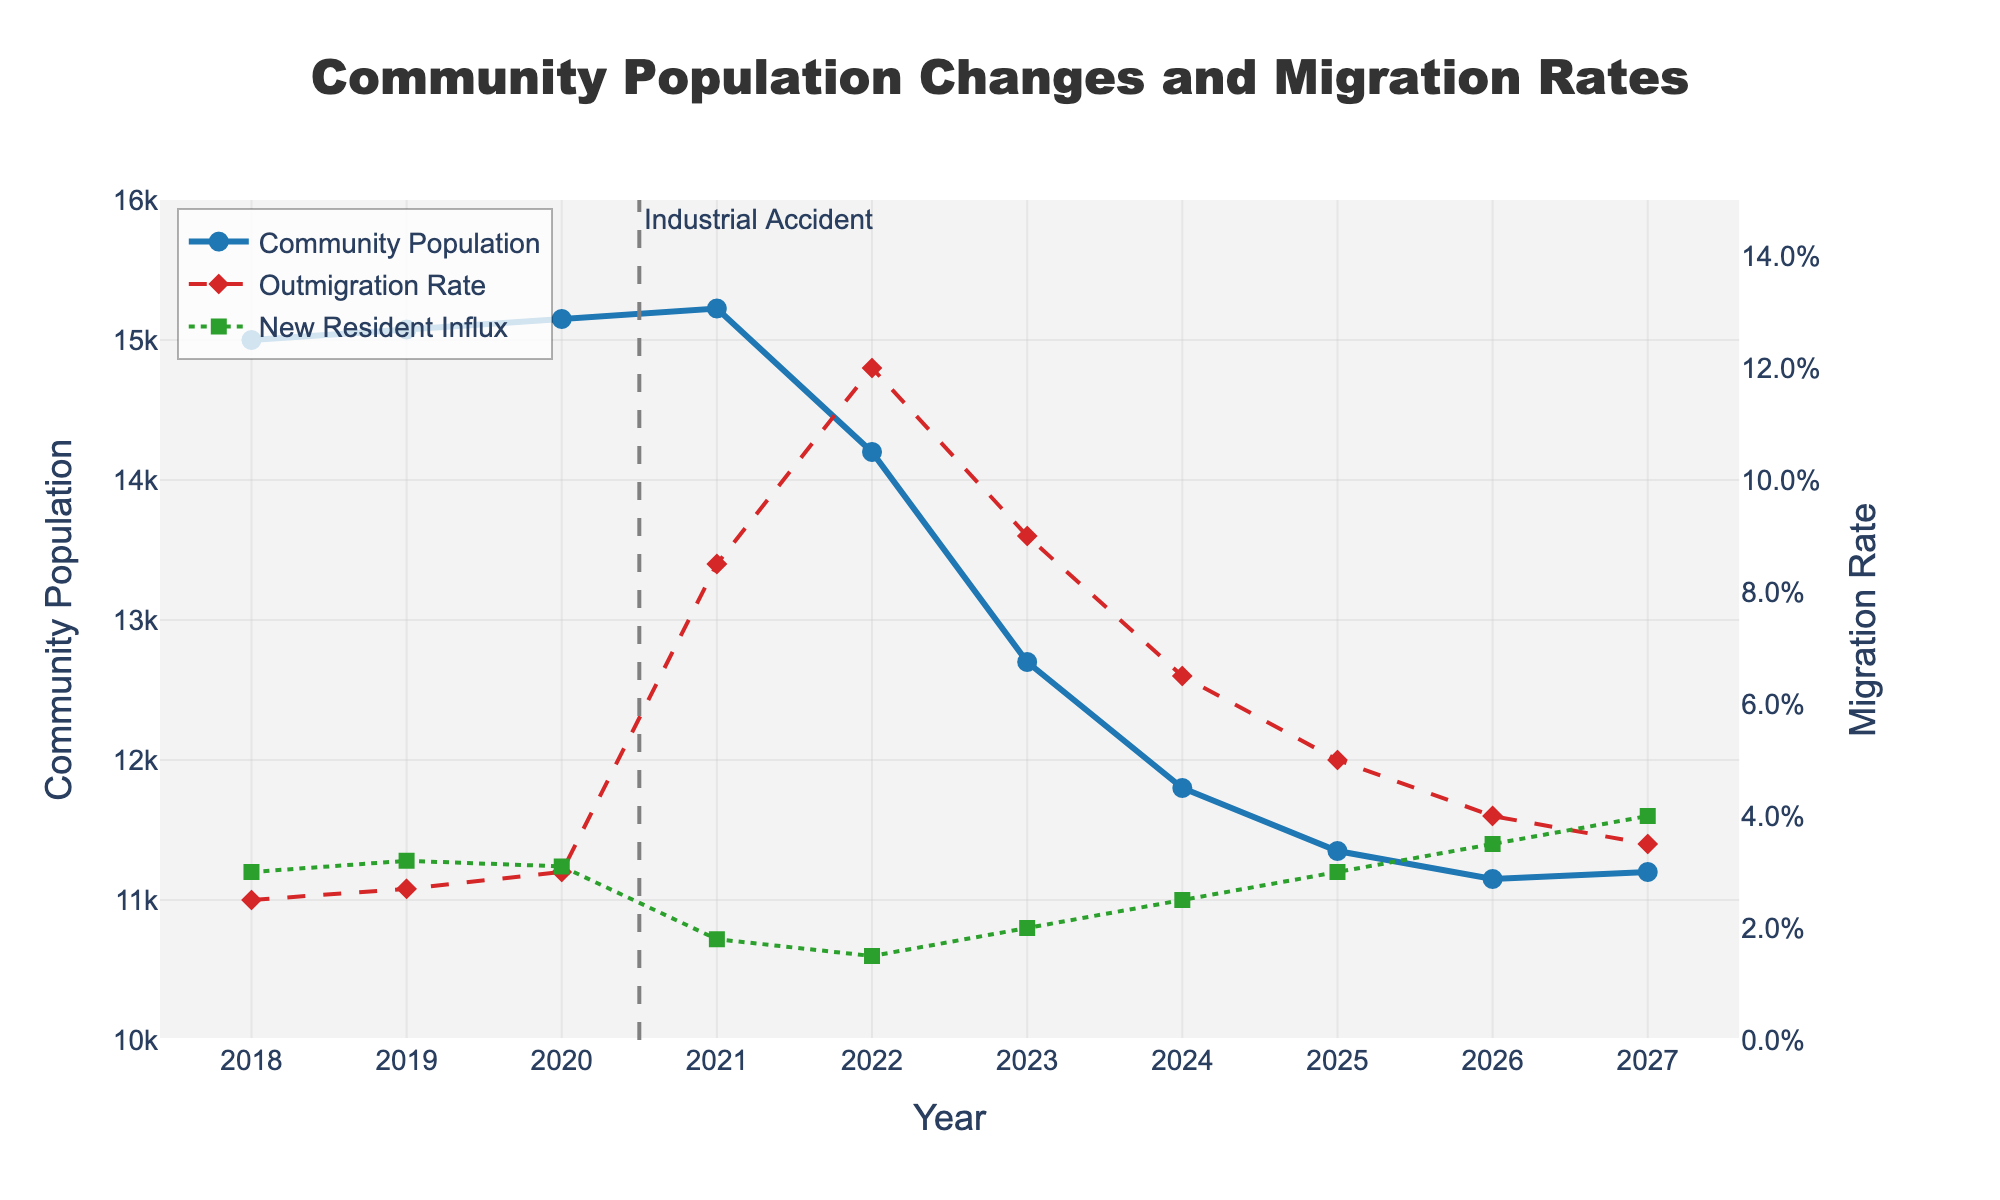What's the population trend in the community from 2018 to 2027? To determine the population trend, observe the blue line in the chart representing the 'Community Population.' From 2018 to 2020, there's a gradual increase in population. However, starting from 2021, there is a sharp decline continuing until 2027, indicating an overall decreasing trend.
Answer: Downward Trend How did the outmigration rate change from 2020 to 2022? Examine the red dashed line representing the 'Outmigration Rate.' It increases significantly from 3.0% in 2020 to 8.5% in 2021, and peaks at 12.0% in 2022.
Answer: Increased Which year had the highest new resident influx? Check the green dotted line for 'New Resident Influx' over the years. The highest influx occurs at 4.0% in 2027.
Answer: 2027 Did the population increase or decrease in 2021, and by how much? Note the population in 2020 (15150) and 2021 (15225). The population increased from 15150 to 15225, making the difference 75.
Answer: Increased by 75 Did the community population ever drop below 12,000? If so, in which years? Look at the blue line. The population drops below 12,000 starting from 2024 and remains below it in 2025 and 2026.
Answer: 2024, 2025, 2026 What is the difference between the outmigration rate and new resident influx in 2022? The outmigration rate in 2022 is 12.0%, and the new resident influx is 1.5%. Subtract the latter from the former to get 10.5%.
Answer: 10.5% In which year do both the outmigration rate and new resident influx show the least values on the chart? Scan both red and green lines. The least values on both lines are: outmigration rate (2.5%) and new resident influx (1.5%) in 2018 and 2022, respectively.
Answer: 2018, 2022 What visual indication is there to mark the year of the industrial accident? Look for any standout visual elements, such as a vertical line or annotation. A vertical dashed gray line is marked at 2020 with the annotation "Industrial Accident."
Answer: Vertical dashed line How does the new resident influx in 2021 compare with that in 2026? Compare the green dotted values for these years. In 2021, it is 1.8%, and in 2026, it is 3.5%.
Answer: Lower in 2021 Evaluate the compound change in outmigration rate between 2020 and 2027? Check the outmigration rates in 2020 (3.0%) and 2027 (3.5%). The difference is 0.5%.
Answer: Increased by 0.5% 